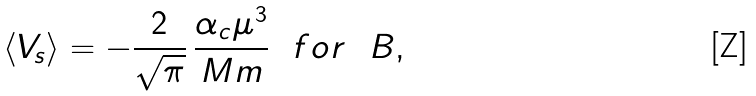Convert formula to latex. <formula><loc_0><loc_0><loc_500><loc_500>\langle V _ { s } \rangle = - { \frac { 2 } { \sqrt { \pi } } } \, { \frac { \alpha _ { c } \mu ^ { 3 } } { M m } } \ \ f o r \ \ B , \quad</formula> 